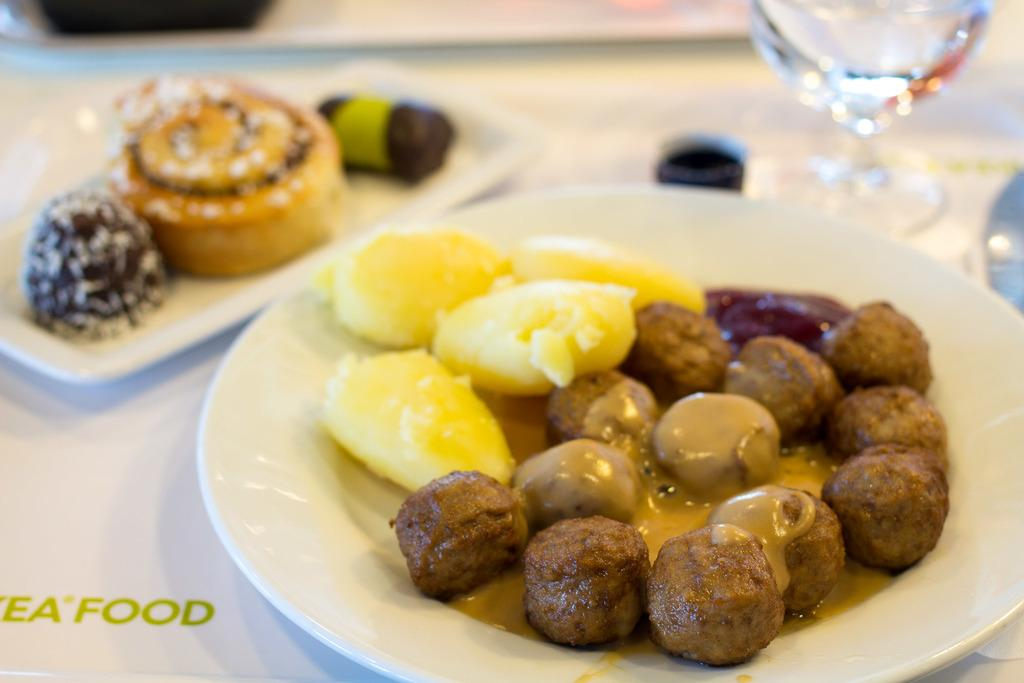What is the main piece of furniture in the image? There is a table in the image. How many plates are on the table? There are two plates on the table. What else is on the table besides the plates? There is a glass on the table. What is in the plates? There is food in the plates. Where can some text be found in the image? There is some text at the left bottom of the image. How many girls are sitting quietly at the table in the image? There are no girls present in the image; it only shows a table with plates, a glass, and food. 